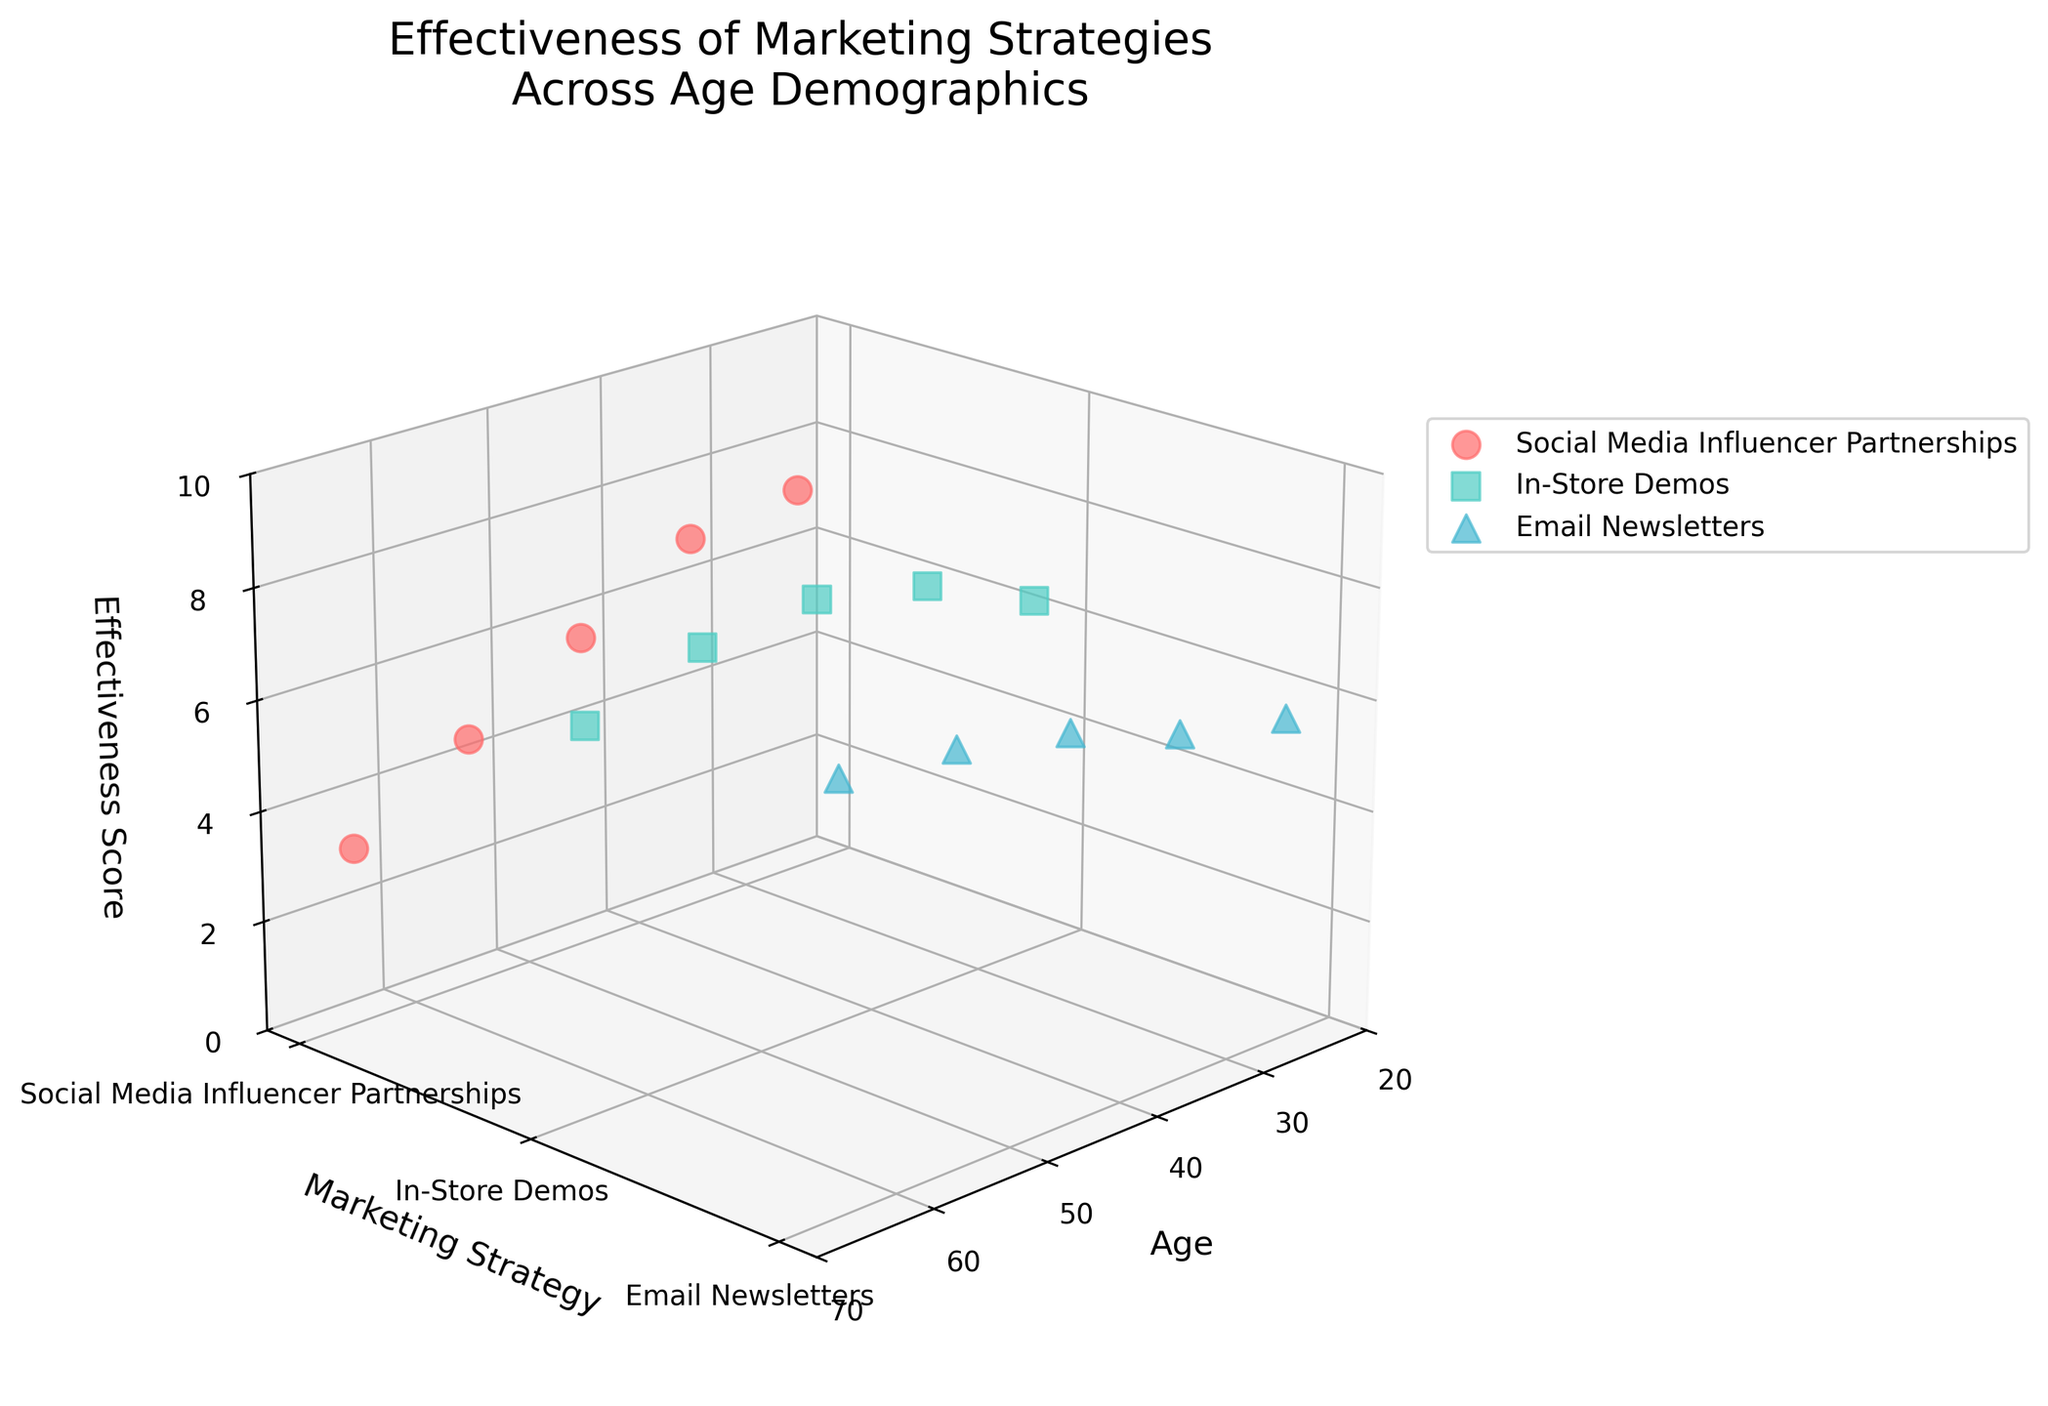Who is the most effective marketing strategy for the 35 age group? To determine this, look at the part of the plot where the age is 35. For each 35-year-old data point, check the effectiveness scores for the various marketing strategies. The In-Store Demos strategy has the highest effectiveness score.
Answer: In-Store Demos What is the trend for the effectiveness of Social Media Influencer Partnerships as age increases? By examining the effectiveness scores for the Social Media Influencer Partnerships strategy across different ages, you can see that the scores decline steadily from 25 to 65 years.
Answer: Decreasing Which age group shows the highest effectiveness score for In-Store Demos? For each age group, identify the effectiveness score for the In-Store Demos strategy. The age group 45 has the highest score with 7.8.
Answer: 45 How does the effectiveness of Email Newsletters for the 55 age group compare to that of Social Media Influencer Partnerships for the same age group? For age group 55, compare the effectiveness scores for Email Newsletters (7.3) and Social Media Influencer Partnerships (4.5). The Email Newsletters strategy is more effective.
Answer: Email Newsletters is more effective What is the average effectiveness score for Social Media Influencer Partnerships across all age groups? Add the effectiveness scores for Social Media Influencer Partnerships (7.2, 6.9, 5.7, 4.5, 3.2), divide by the number of age groups (5). Calculation: (7.2 + 6.9 + 5.7 + 4.5 + 3.2) / 5 = 5.5
Answer: 5.5 What is the age range covered in the plot? The x-axis represents age, with the data points spanning from 25 to 65 years old.
Answer: 25 to 65 Which marketing strategy has the most consistent effectiveness scores across different age groups? Identify the marketing strategy whose scores remain relatively stable across ages. Email Newsletters has scores ranging from 5.8 to 7.5, showing less variability than the other strategies.
Answer: Email Newsletters For ages 25 and 45, which marketing strategy has the greatest difference in effectiveness scores? Compare the effectiveness scores for each marketing strategy between ages 25 (In-Store Demos: 6.5, Email Newsletters: 5.8, Social Media Influencer Partnerships: 7.2) and 45 (In-Store Demos: 7.8, Email Newsletters: 6.9, Social Media Influencer Partnerships: 5.7). The greatest difference is for the In-Store Demos strategy, with scores 6.5 (25) and 7.8 (45), a difference of 1.3.
Answer: In-Store Demos How many unique marketing strategies are represented in the plot? The y-axis lists the marketing strategies, which can be counted. There are three unique marketing strategies: Social Media Influencer Partnerships, In-Store Demos, and Email Newsletters.
Answer: 3 